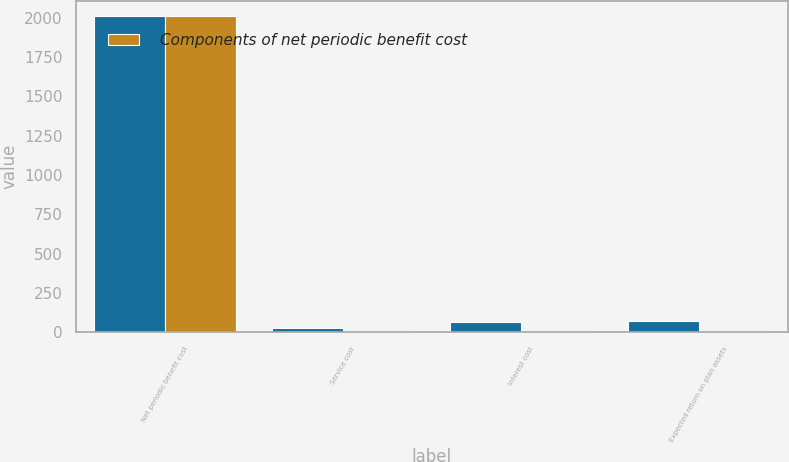Convert chart. <chart><loc_0><loc_0><loc_500><loc_500><stacked_bar_chart><ecel><fcel>Net periodic benefit cost<fcel>Service cost<fcel>Interest cost<fcel>Expected return on plan assets<nl><fcel>nan<fcel>2010<fcel>25<fcel>62<fcel>70<nl><fcel>Components of net periodic benefit cost<fcel>2010<fcel>6<fcel>9<fcel>9<nl></chart> 